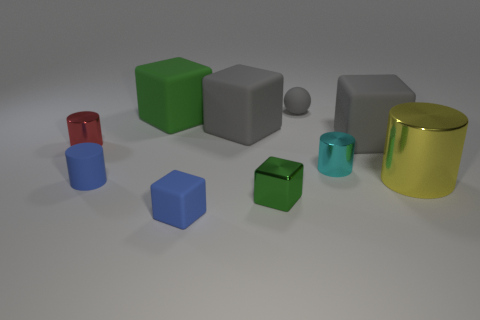Subtract all red cylinders. How many green blocks are left? 2 Subtract all cyan cylinders. How many cylinders are left? 3 Subtract 2 blocks. How many blocks are left? 3 Subtract all big green blocks. How many blocks are left? 4 Subtract all brown cylinders. Subtract all gray cubes. How many cylinders are left? 4 Add 4 rubber spheres. How many rubber spheres exist? 5 Subtract 0 cyan spheres. How many objects are left? 10 Subtract all cylinders. How many objects are left? 6 Subtract all red cylinders. Subtract all small red cylinders. How many objects are left? 8 Add 1 small cubes. How many small cubes are left? 3 